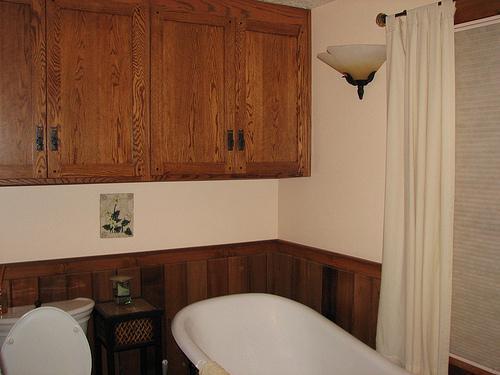How many lamps are there?
Give a very brief answer. 1. 